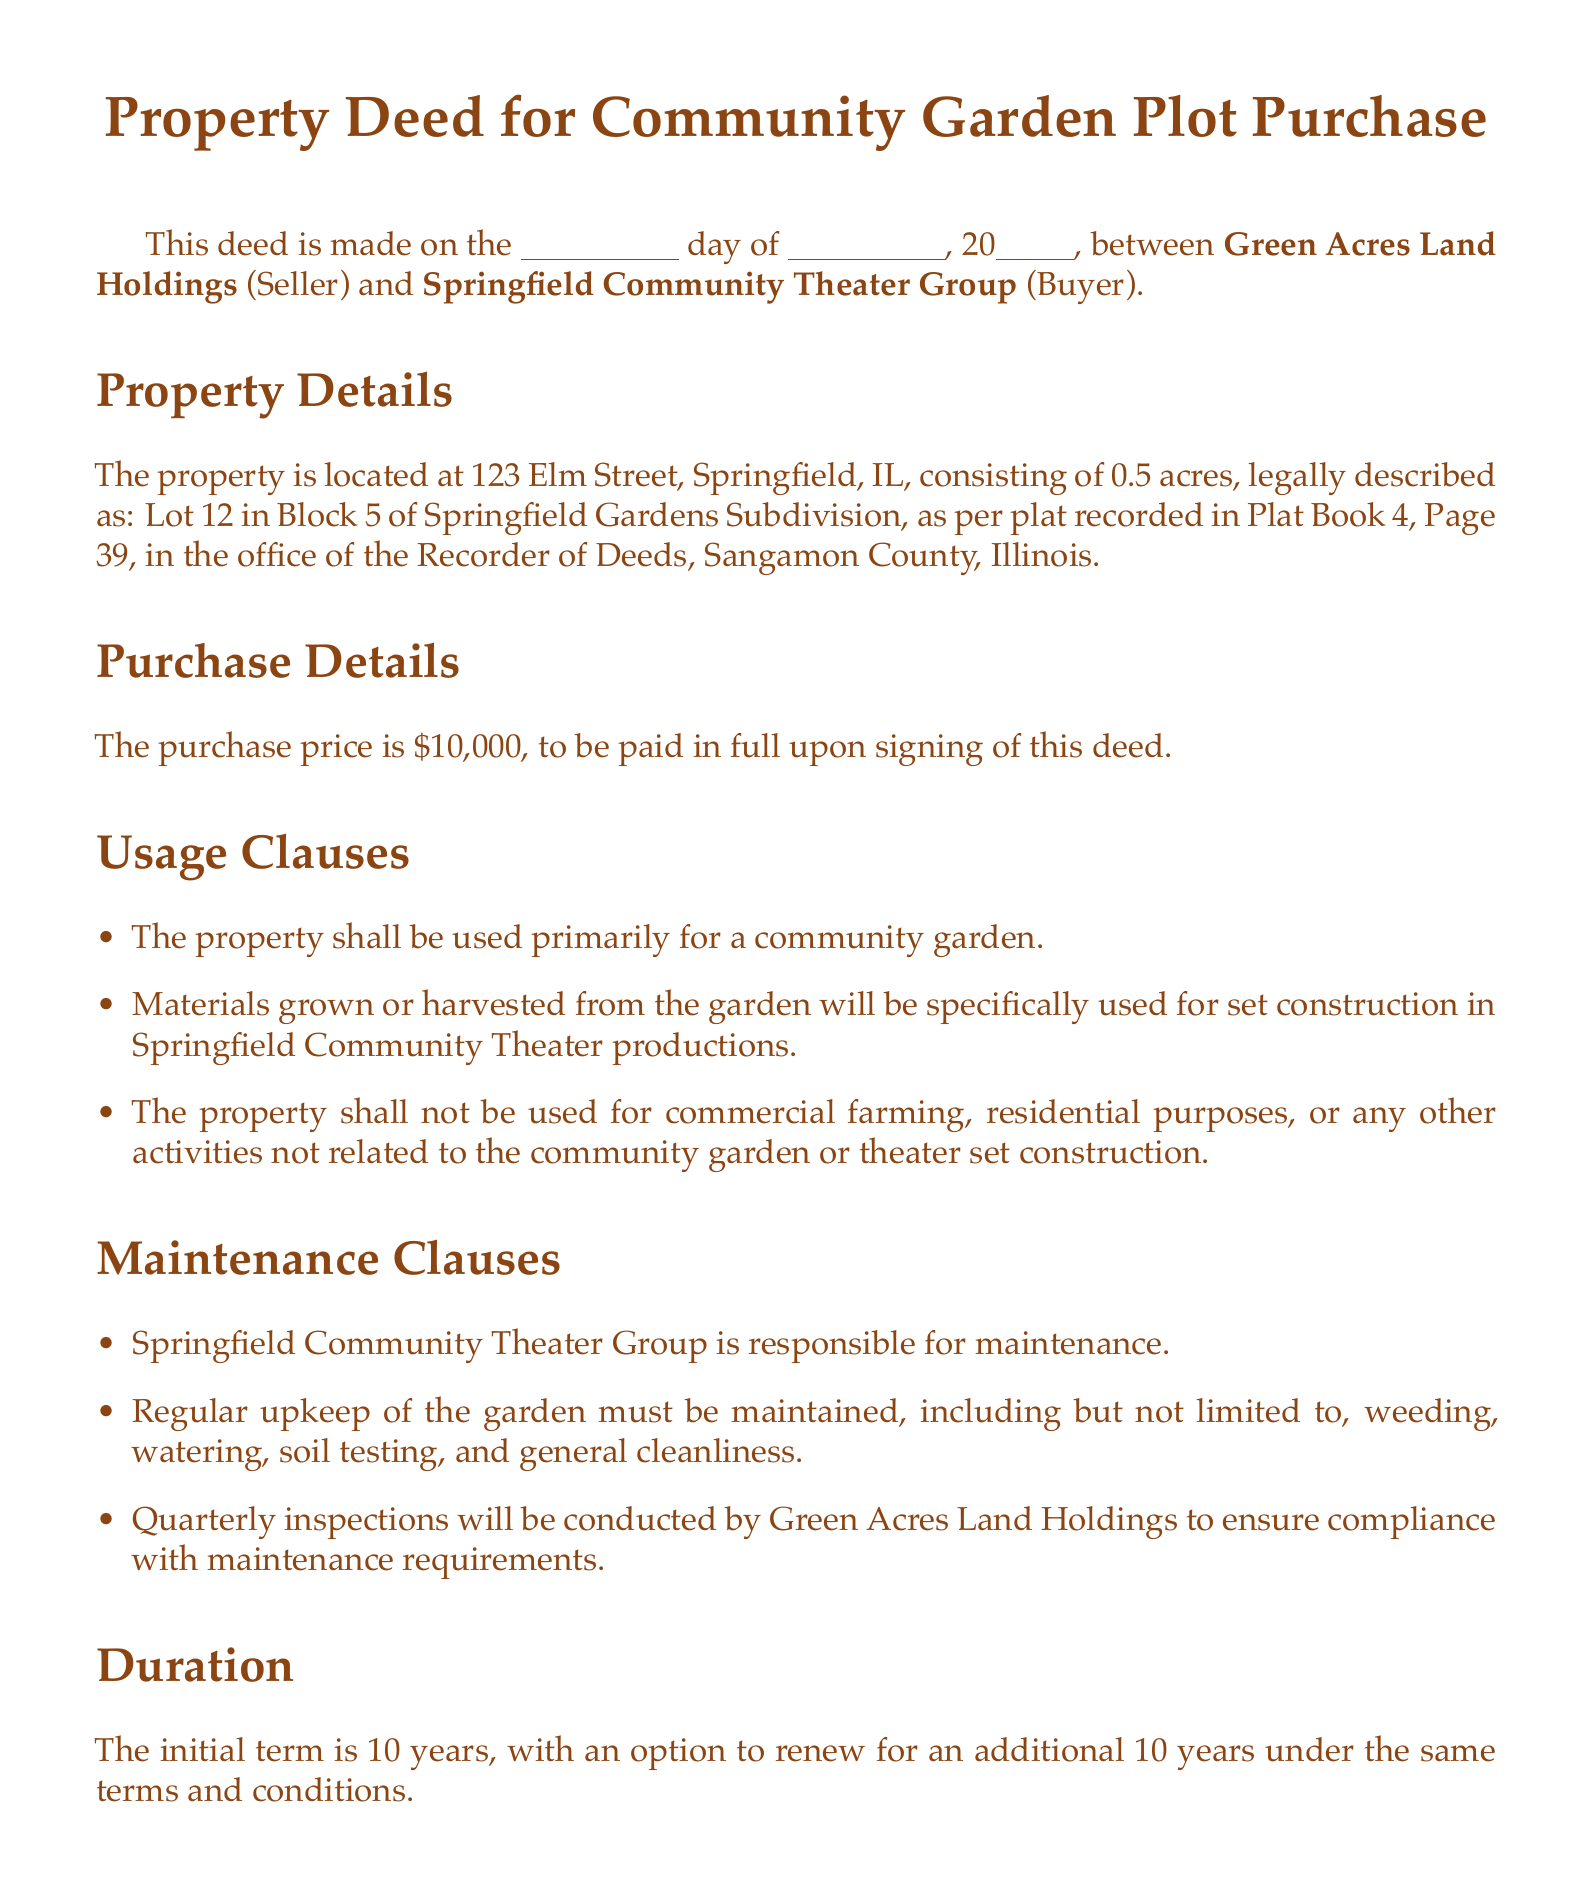What is the property address? The property address is specified in the document as the location of the plot being deeded.
Answer: 123 Elm Street, Springfield, IL Who is the seller? The seller is identified in the deed as the entity transferring ownership of the property.
Answer: Green Acres Land Holdings What is the purchase price? The purchase price is laid out clearly in the purchase details section of the document.
Answer: $10,000 How long is the initial term for the property use? The term is mentioned in the duration section, stating the length of the initial agreement.
Answer: 10 years What is Springfield Community Theater Group responsible for? The responsibilities of the buyer are outlined in the maintenance clauses.
Answer: Maintenance What activities are prohibited on the property? The usage clauses outline the restrictions on property use.
Answer: Commercial farming Who will conduct the quarterly inspections? The entity responsible for the inspections is specified in the maintenance clauses.
Answer: Green Acres Land Holdings What must be maintained in the garden? The maintenance requirements detail what needs to be upheld in the garden.
Answer: Regular upkeep What is the option duration for renewal? This information is included in the duration section, detailing possible further arrangements.
Answer: 10 years 